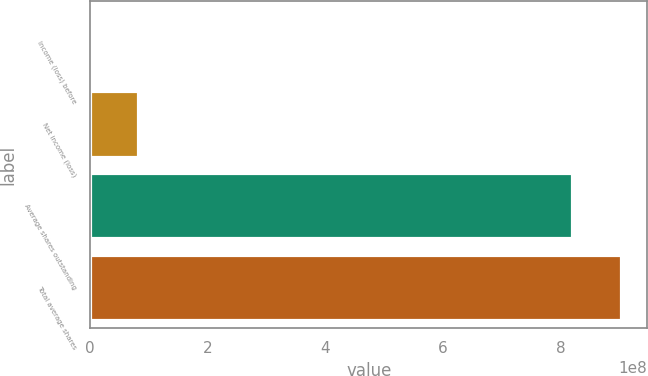Convert chart. <chart><loc_0><loc_0><loc_500><loc_500><bar_chart><fcel>Income (loss) before<fcel>Net income (loss)<fcel>Average shares outstanding<fcel>Total average shares<nl><fcel>220<fcel>8.20295e+07<fcel>8.20293e+08<fcel>9.02322e+08<nl></chart> 